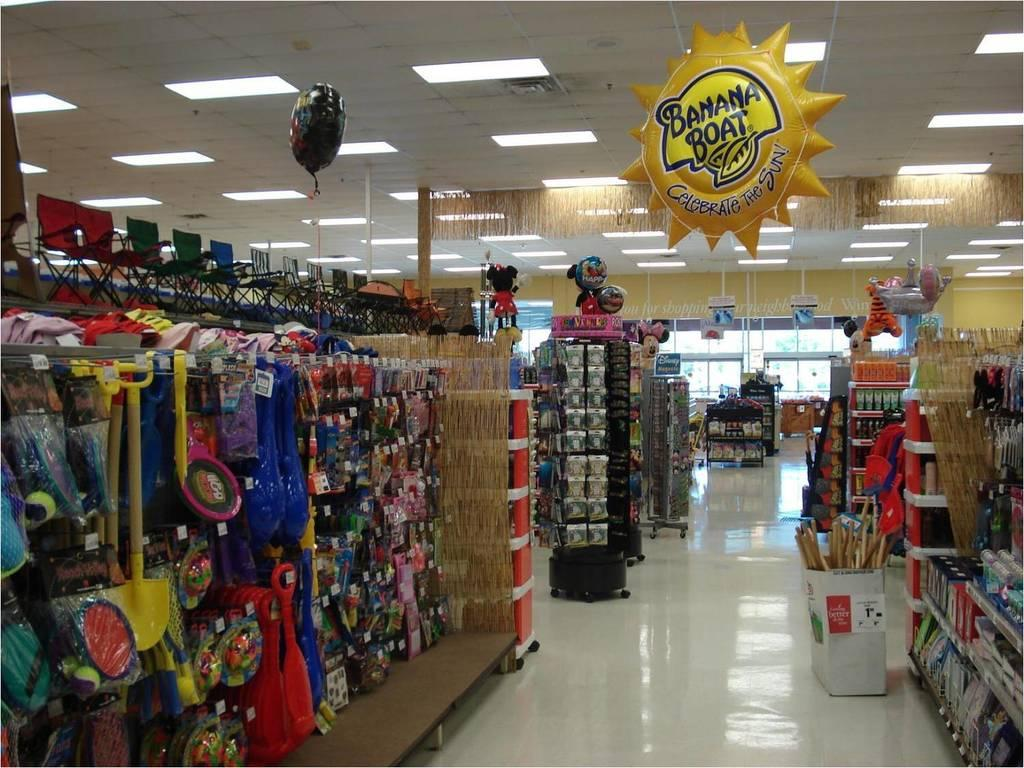<image>
Present a compact description of the photo's key features. an aisle of a store near a Banana Boat balloon 